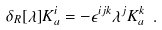Convert formula to latex. <formula><loc_0><loc_0><loc_500><loc_500>\delta _ { R } [ \lambda ] K ^ { i } _ { a } = - \epsilon ^ { i j k } \lambda ^ { j } K ^ { k } _ { a } \ .</formula> 